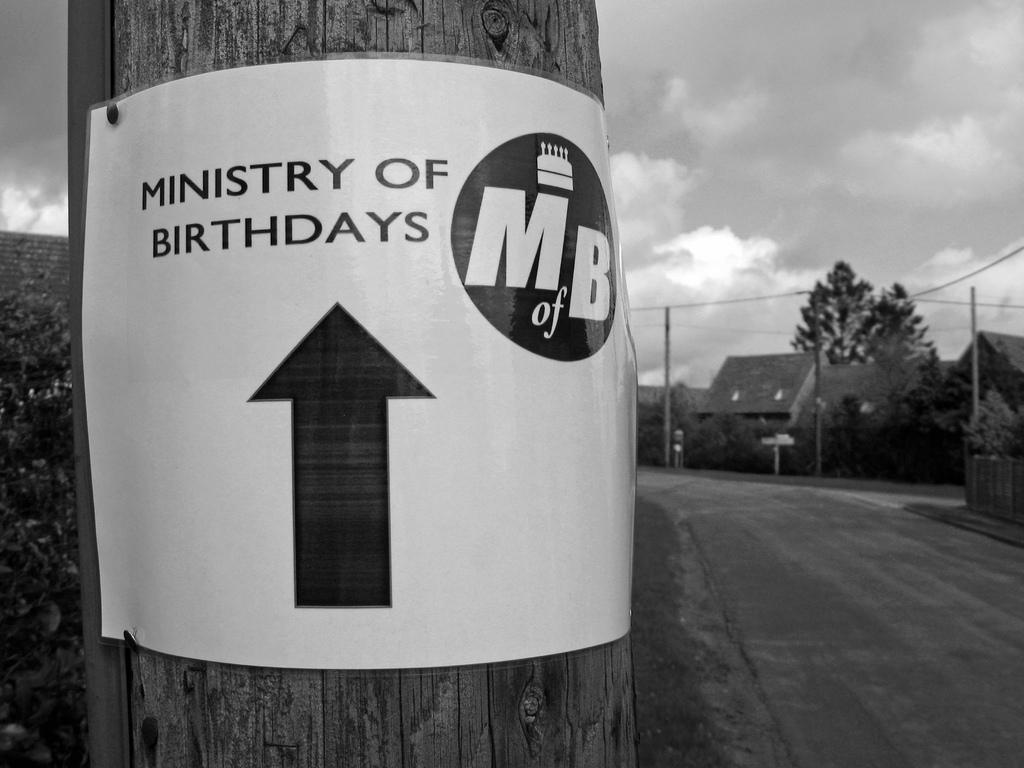What are the initials on the sign?
Keep it short and to the point. Mb. What is this ministry for?
Provide a succinct answer. Birthdays. 